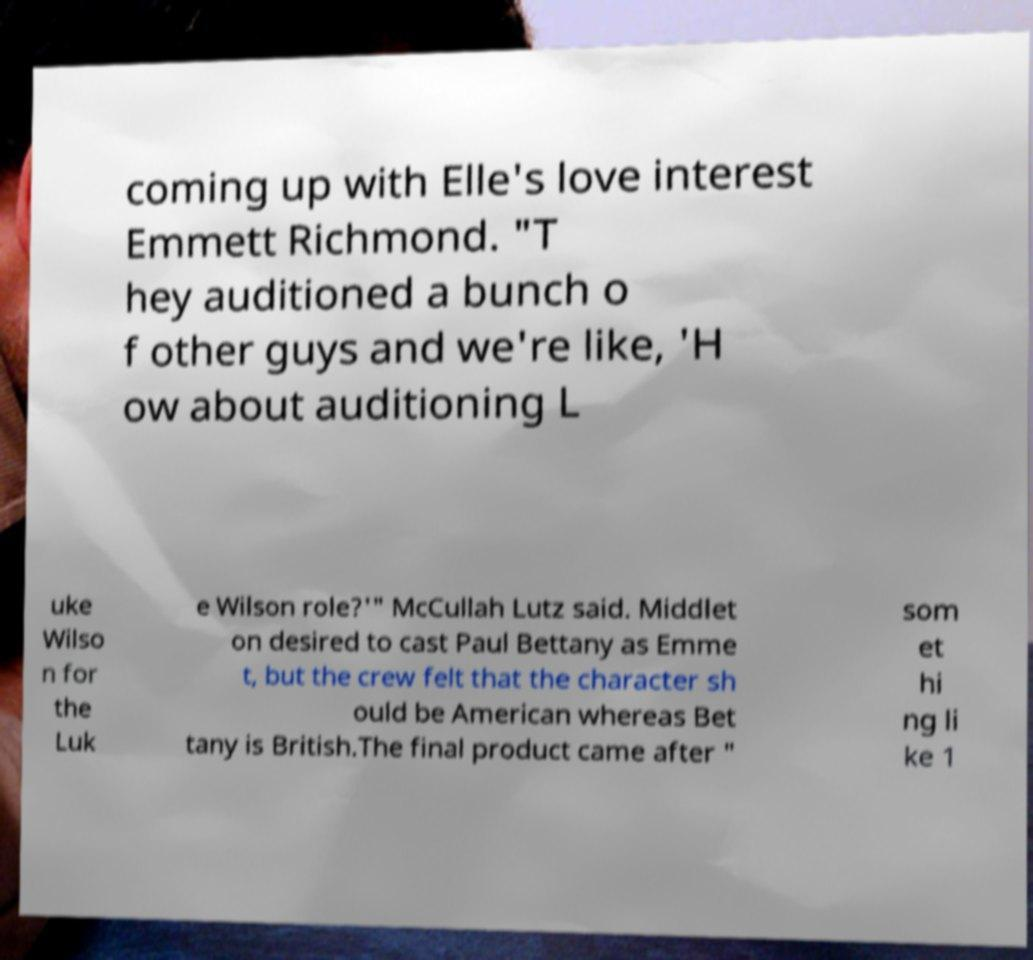For documentation purposes, I need the text within this image transcribed. Could you provide that? coming up with Elle's love interest Emmett Richmond. "T hey auditioned a bunch o f other guys and we're like, 'H ow about auditioning L uke Wilso n for the Luk e Wilson role?'" McCullah Lutz said. Middlet on desired to cast Paul Bettany as Emme t, but the crew felt that the character sh ould be American whereas Bet tany is British.The final product came after " som et hi ng li ke 1 